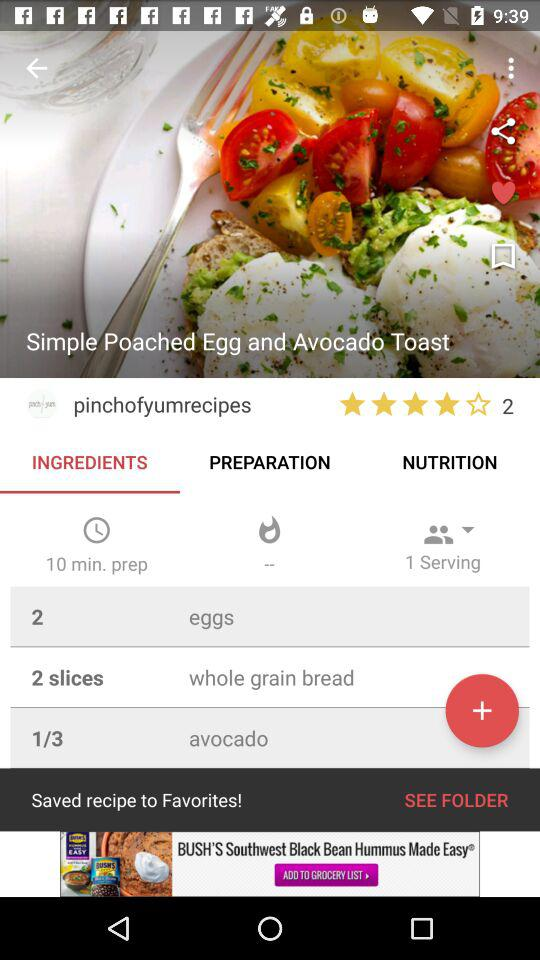How many people rated the dish? The dish was rated by 2 people. 